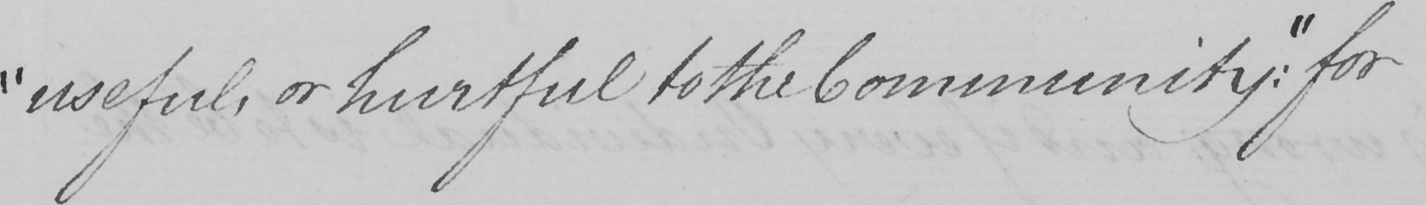Please provide the text content of this handwritten line. " useful , or hurtful to the Community :  "  for 